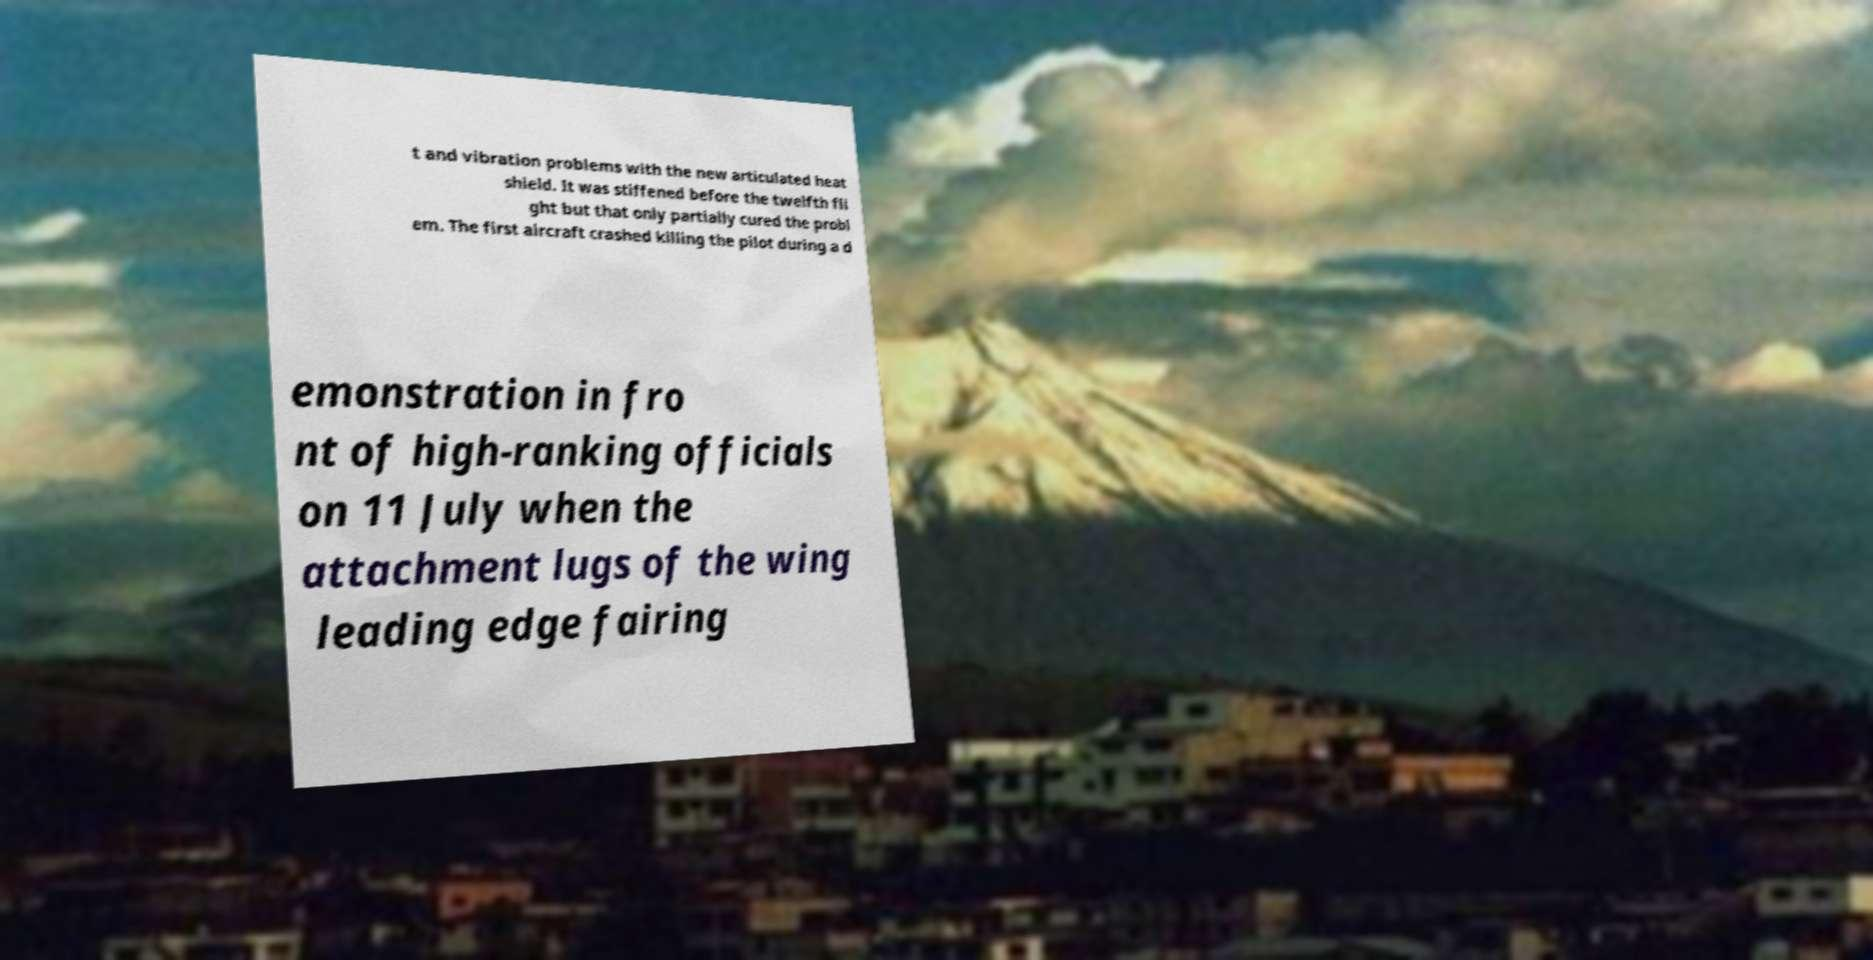Please read and relay the text visible in this image. What does it say? t and vibration problems with the new articulated heat shield. It was stiffened before the twelfth fli ght but that only partially cured the probl em. The first aircraft crashed killing the pilot during a d emonstration in fro nt of high-ranking officials on 11 July when the attachment lugs of the wing leading edge fairing 